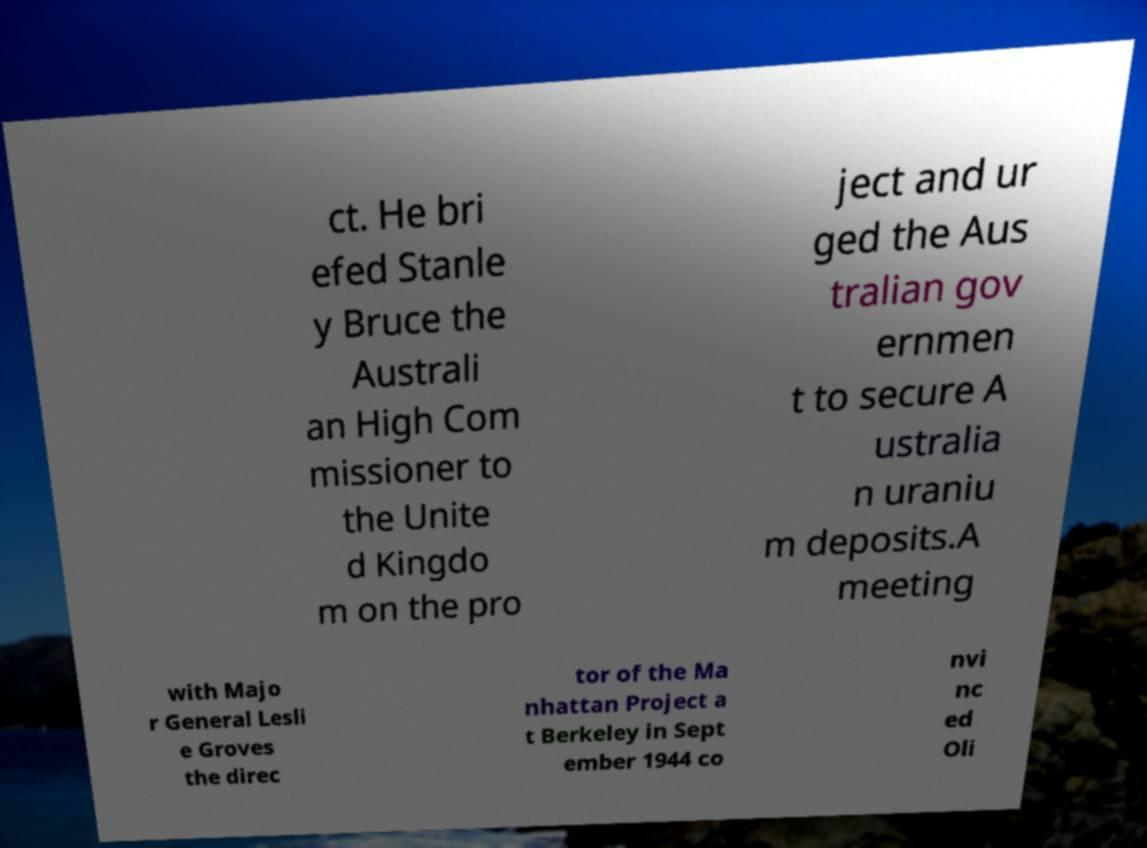Could you extract and type out the text from this image? ct. He bri efed Stanle y Bruce the Australi an High Com missioner to the Unite d Kingdo m on the pro ject and ur ged the Aus tralian gov ernmen t to secure A ustralia n uraniu m deposits.A meeting with Majo r General Lesli e Groves the direc tor of the Ma nhattan Project a t Berkeley in Sept ember 1944 co nvi nc ed Oli 